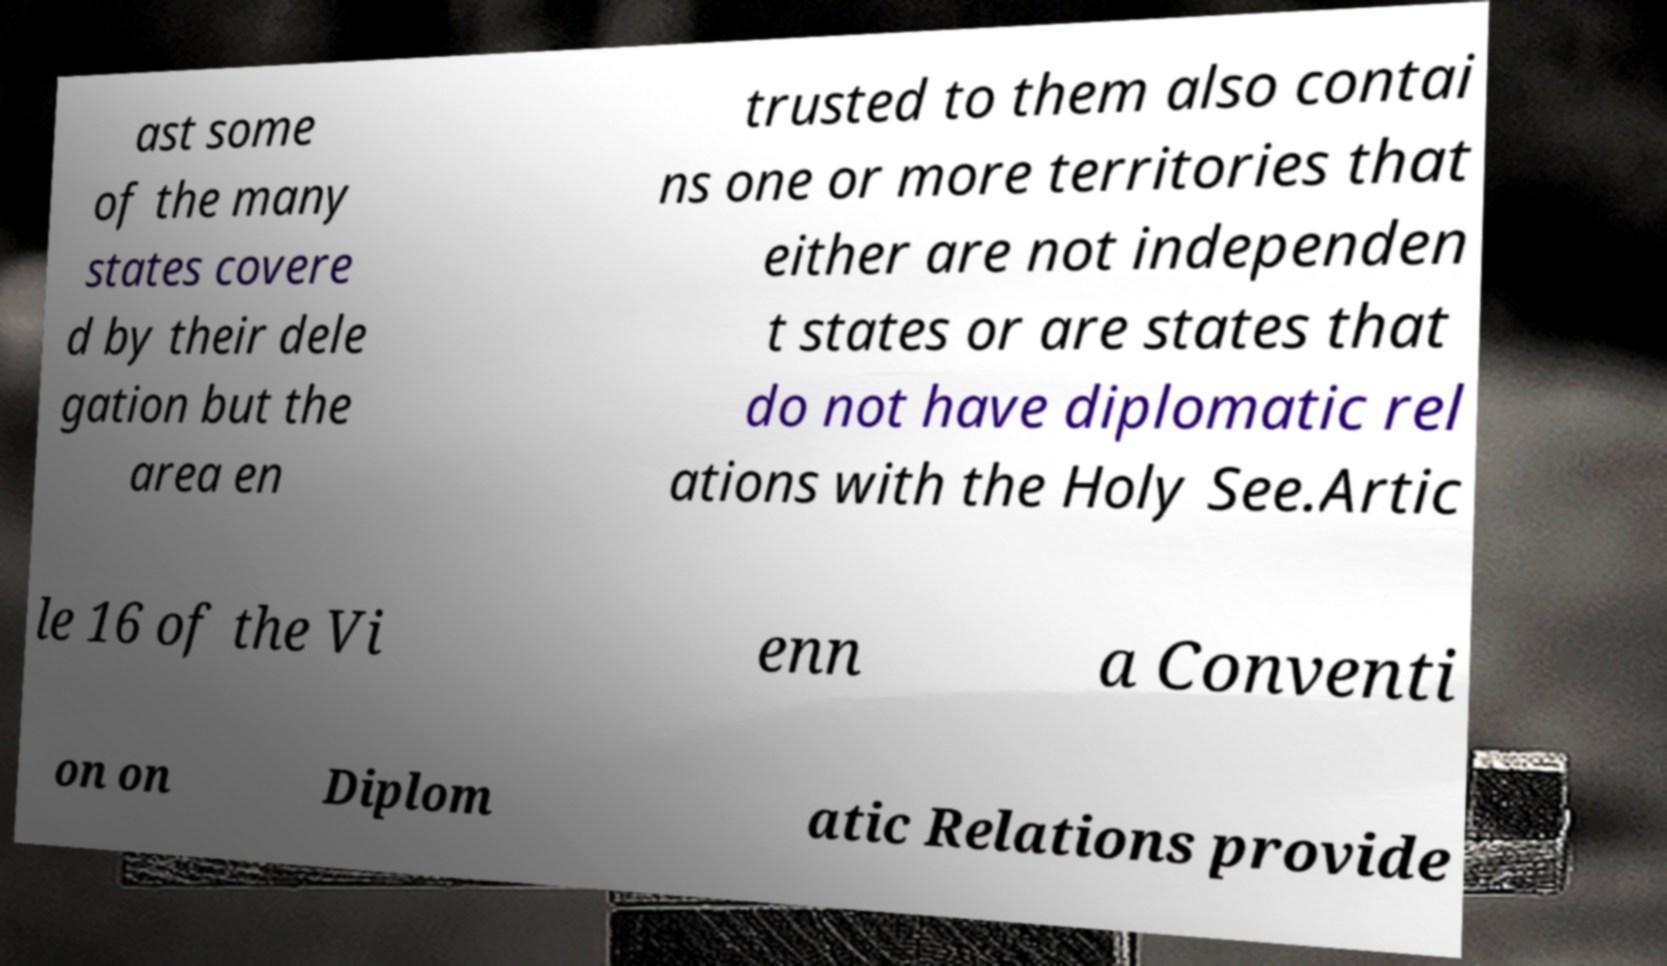Could you extract and type out the text from this image? ast some of the many states covere d by their dele gation but the area en trusted to them also contai ns one or more territories that either are not independen t states or are states that do not have diplomatic rel ations with the Holy See.Artic le 16 of the Vi enn a Conventi on on Diplom atic Relations provide 